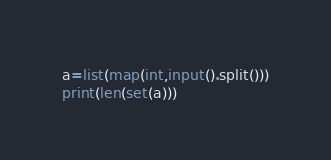<code> <loc_0><loc_0><loc_500><loc_500><_Python_>a=list(map(int,input().split()))
print(len(set(a)))</code> 